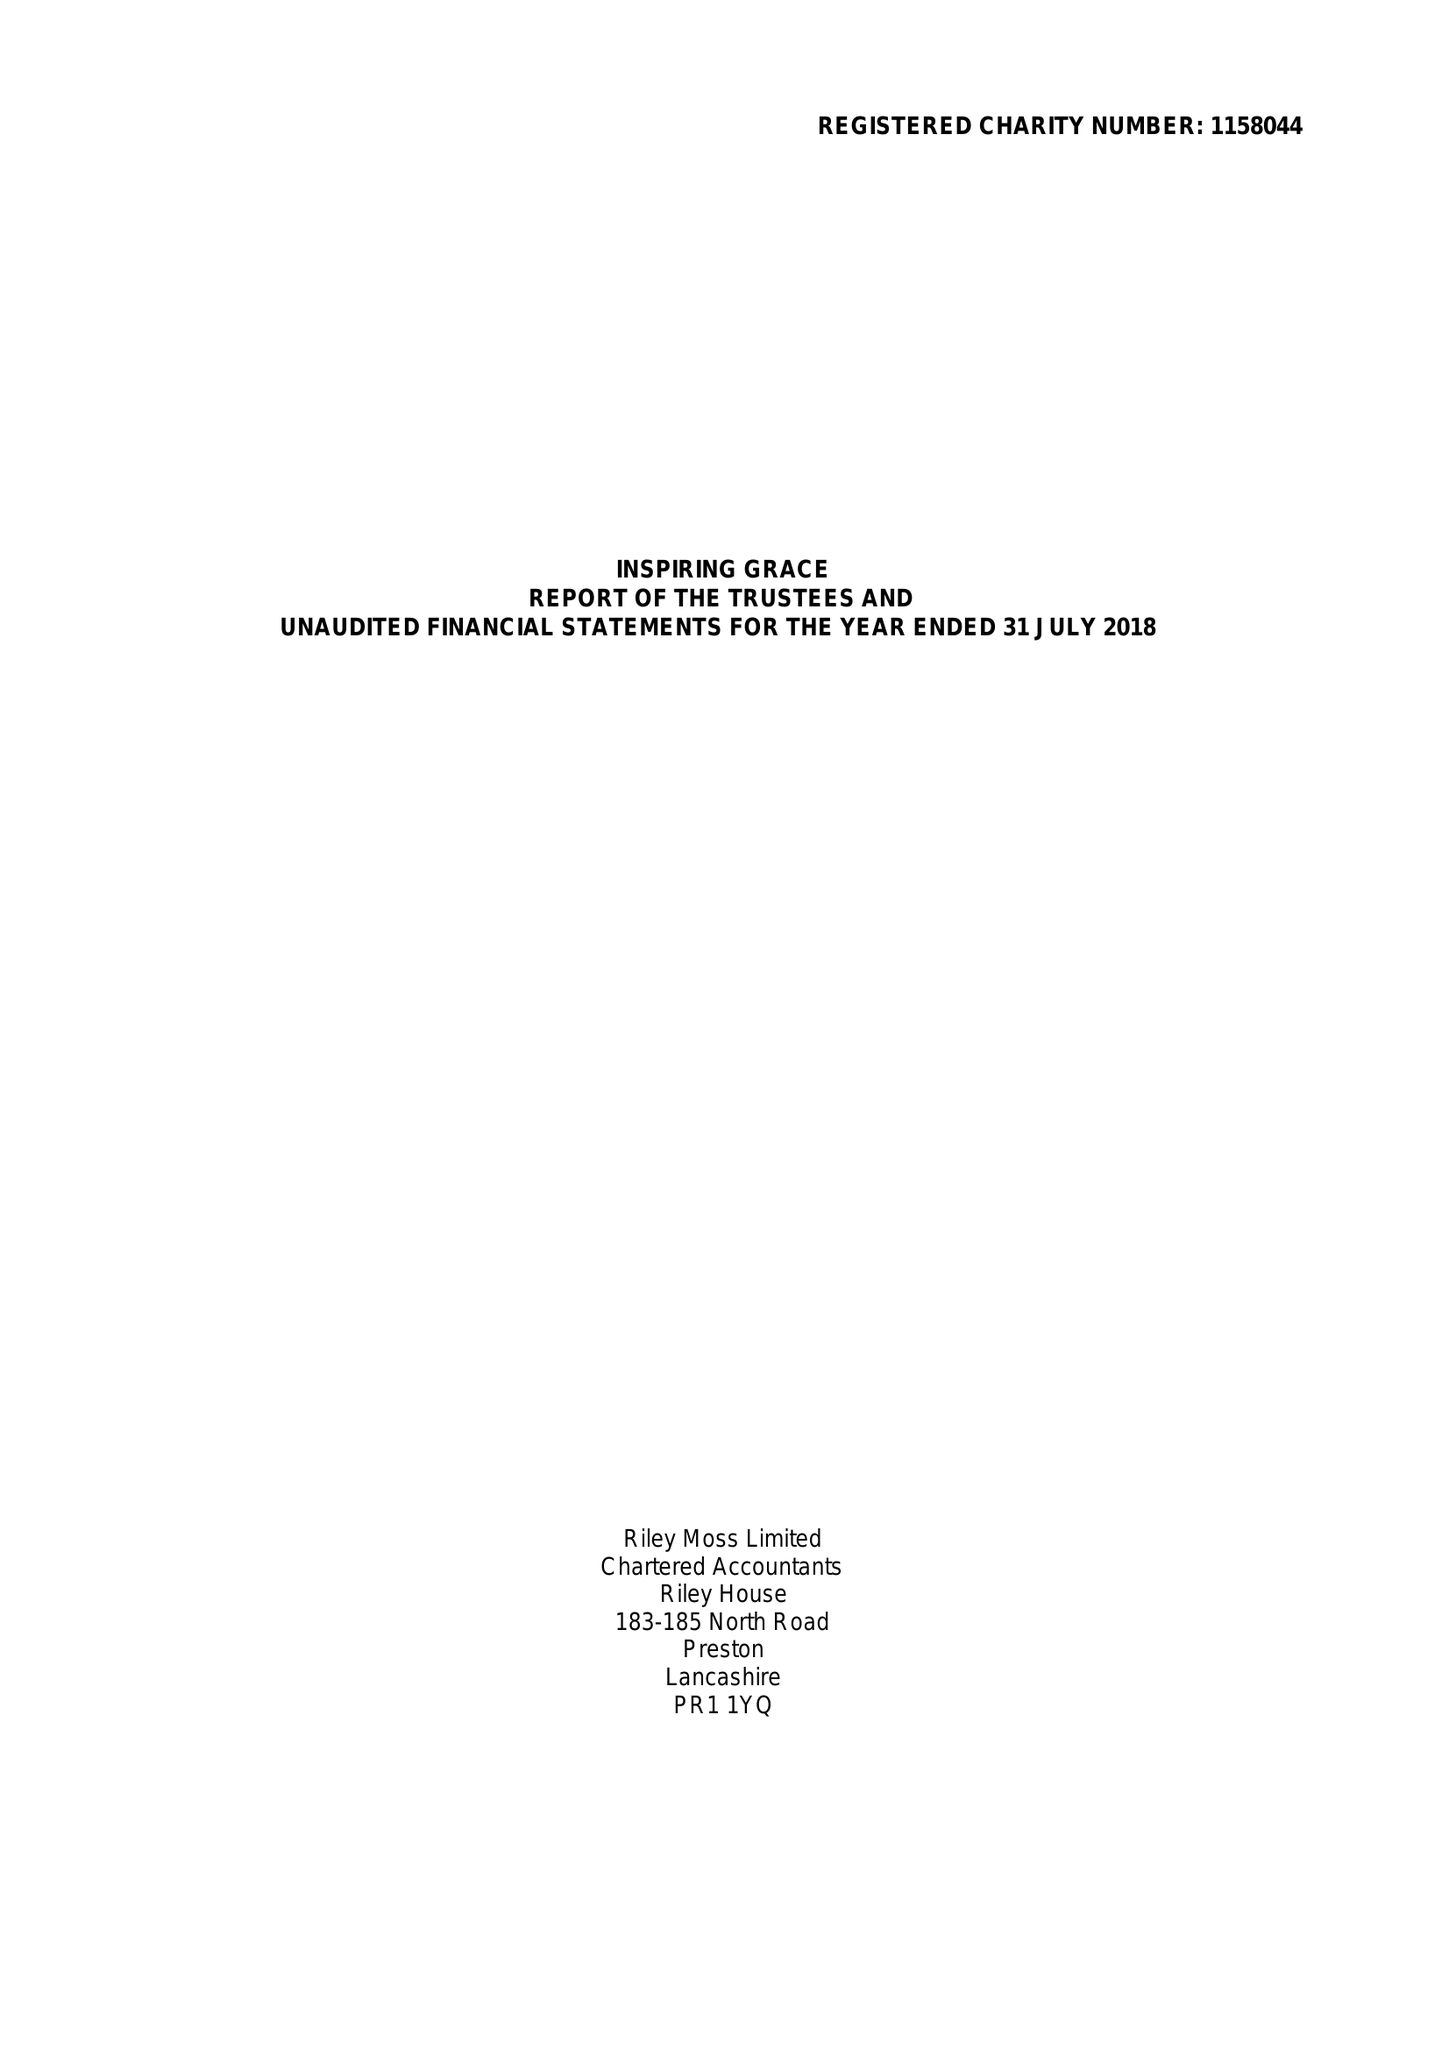What is the value for the address__postcode?
Answer the question using a single word or phrase. BB9 8RT 